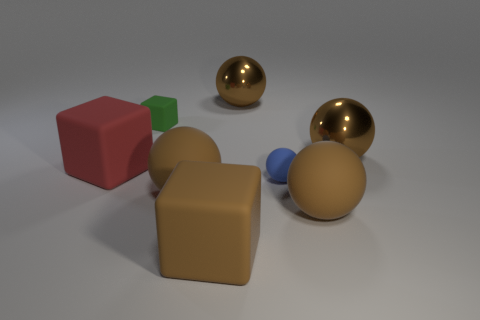Subtract all big brown matte blocks. How many blocks are left? 2 Subtract all yellow cubes. How many brown spheres are left? 4 Add 1 red matte cubes. How many objects exist? 9 Subtract all spheres. How many objects are left? 3 Subtract all brown spheres. How many spheres are left? 1 Subtract 4 spheres. How many spheres are left? 1 Subtract 0 red cylinders. How many objects are left? 8 Subtract all green spheres. Subtract all purple cylinders. How many spheres are left? 5 Subtract all brown cubes. Subtract all green blocks. How many objects are left? 6 Add 2 green things. How many green things are left? 3 